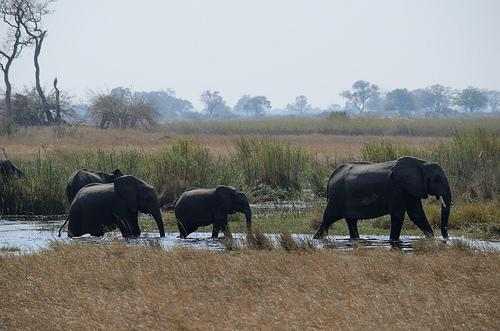What prominent action is being performed by the main subject in the image? The main subject, a group of elephants, is walking in a marsh area with water and vegetation. Identify the main element in the image and provide a brief description. A group of elephants, including adults and young ones, are walking in a marshy area with trees in the distance. Enumerate the significant features that are present within the image. Elephants, marshland, water, trees, trunks, tusks, tall grass, and sky. What are the main elements relating to nature in the image, and their respective sizes? Trees (width: 168, height: 168), tall grass (width: 91, height: 91), and water with grass growing around (width: 495, height: 495). How many elephants are mentioned in the image, and what are they doing? Multiple elephants, specifically categorizations such as adult, young, and baby, are walking through marshy water. State the primary action occurring in the image in a simple sentence. Elephants are walking through water in a marsh. Using descriptive language, express the setting of the image. A tranquil marshland with gentle waters and lush, tall grass, where a family of elephants gracefully makes their way amidst a picturesque landscape of distant trees. In a single sentence, describe the overall atmosphere of the image. It portrays a peaceful and serene scene of elephants roaming through a marshy area, surrounded by the beauty of nature. Pick one detail from the image and provide an elaborate description. The tusk of the largest elephant is visible near the front, with a width of 14 and height of 14, symbolizing its strong and prominent presence. Describe the relationship between the elephants and their surroundings. The elephants, both adults and young, are peacefully and harmoniously coexisting within their marshy environment, surrounded by water, vegetation, and distant trees. 